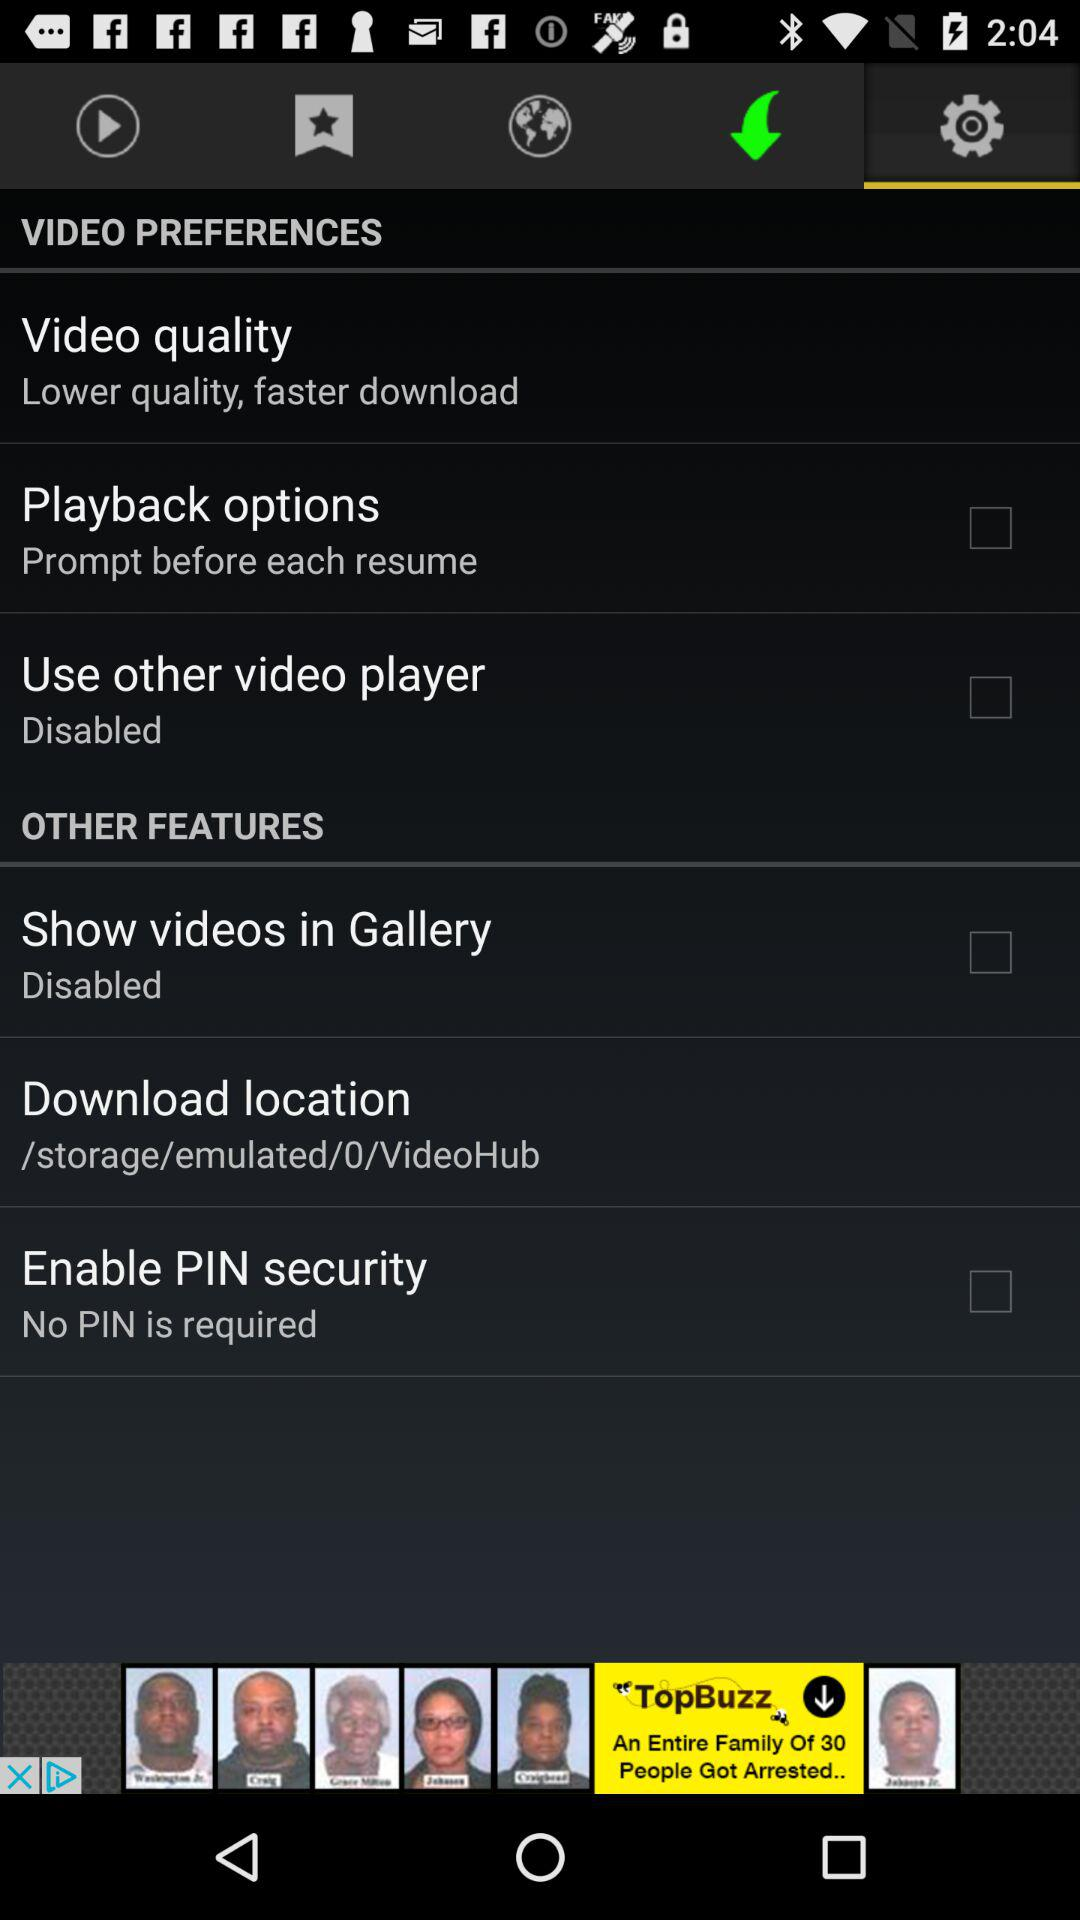Which tab am I on? You are on the "Settings" tab. 